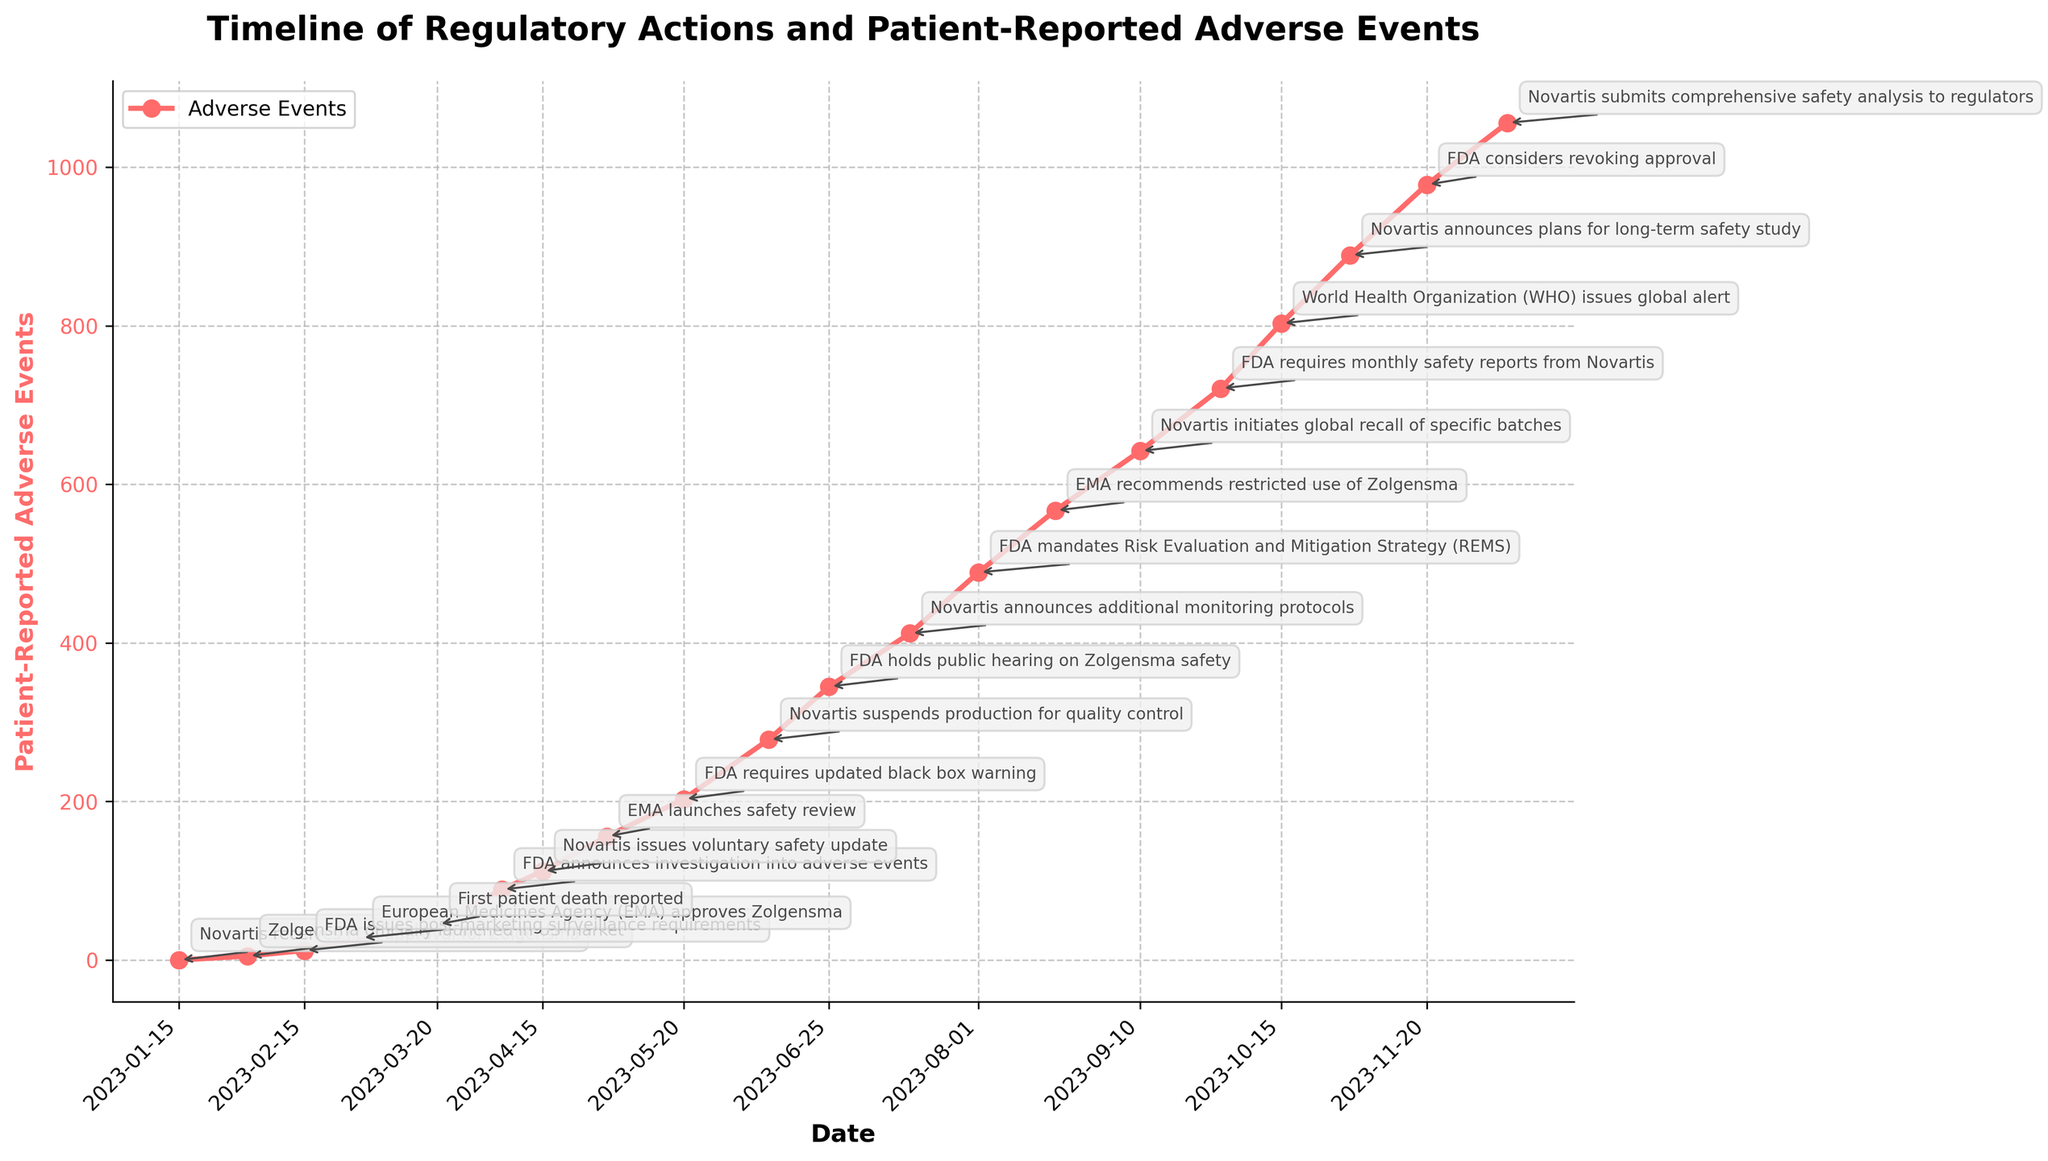When did the FDA first announce an investigation into Zolgensma's adverse events? The specific date for the FDA's announcement is labeled on the timeline of the figure. The annotation indicates that the investigation was announced on April 5, 2023.
Answer: April 5, 2023 How many patient-reported adverse events were noted when Novartis suspended production for quality control? By locating the corresponding date (June 10, 2023) on the x-axis and reading the y-axis value, it is clear that there were 278 patient-reported adverse events at that point.
Answer: 278 What is the difference in the number of patient-reported adverse events between the first patient death reported and the subsequent FDA's public hearing? The first patient death was reported on March 20, 2023, with 45 events, and the FDA held a public hearing on June 25, 2023, with 345 events. The difference is 345 - 45 = 300.
Answer: 300 Which regulatory action is associated with the highest spike in patient-reported adverse events? The highest point on the line graph corresponds to the World Health Organization issuing a global alert. This can be interpreted visually as the peak with 803 adverse events noted on the chart.
Answer: WHO issues global alert Compare the adverse event levels before and after the FDA required updated black box warning. How much did they increase? Before the FDA's requirement (May 20, 2023), there were 203 events. Afterward (June 10, 2023), there were 278 events. The increase is 278 - 203 = 75.
Answer: 75 How many days after the first patient death did the FDA announce post-marketing surveillance requirements? The first patient death was on March 20, 2023, and the FDA issued surveillance requirements on February 15, 2023. The correct interval is from the surveillance requirement to the death, which means going back from March 20 to February 15, that is 14 + 20 = 34 days.
Answer: 34 days (should confirm range or correct if inverse calculated) Estimate how frequently adverse events are reported between Novartis's announcement of new safety monitoring (July 15, 2023) and FDA's monthly safety report requirement (September 30, 2023)? The number of events reported increased from 412 to 721 in the period. This difference is 721 - 412 = 309 events over around 77 days (July 15 to September 30). To find average frequency: 309 events / 77 days ≈ 4.01 events per day.
Answer: Approximately 4 events per day By how much did the number of adverse events increase between the EMA's recommendation of restricted use and Novartis initiating a global recall? EMA recommended restricted use on August 20, 2023 (567 events) and Novartis initiated a recall on September 10, 2023 (642 events). The increase is 642 - 567 = 75.
Answer: 75 On which date did the number of patient-reported adverse events first surpass 200? By checking trend on the figure's timeline, it is visually evident that the adverse events surpass 200 around May 20, 2023, when the FDA required an updated black box warning.
Answer: May 20, 2023 